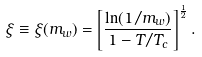Convert formula to latex. <formula><loc_0><loc_0><loc_500><loc_500>\xi \equiv \xi ( m _ { w } ) = \left [ \frac { \ln ( 1 / m _ { w } ) } { 1 - T / T _ { c } } \right ] ^ { \frac { 1 } { 2 } } .</formula> 